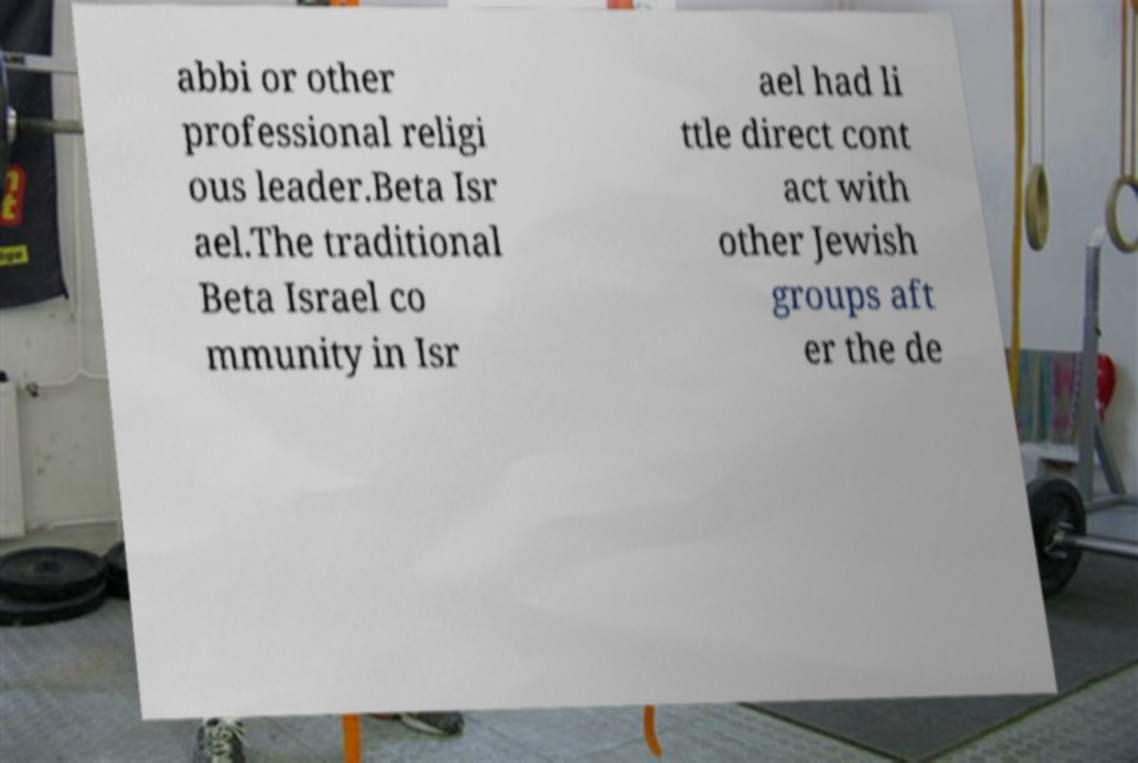For documentation purposes, I need the text within this image transcribed. Could you provide that? abbi or other professional religi ous leader.Beta Isr ael.The traditional Beta Israel co mmunity in Isr ael had li ttle direct cont act with other Jewish groups aft er the de 